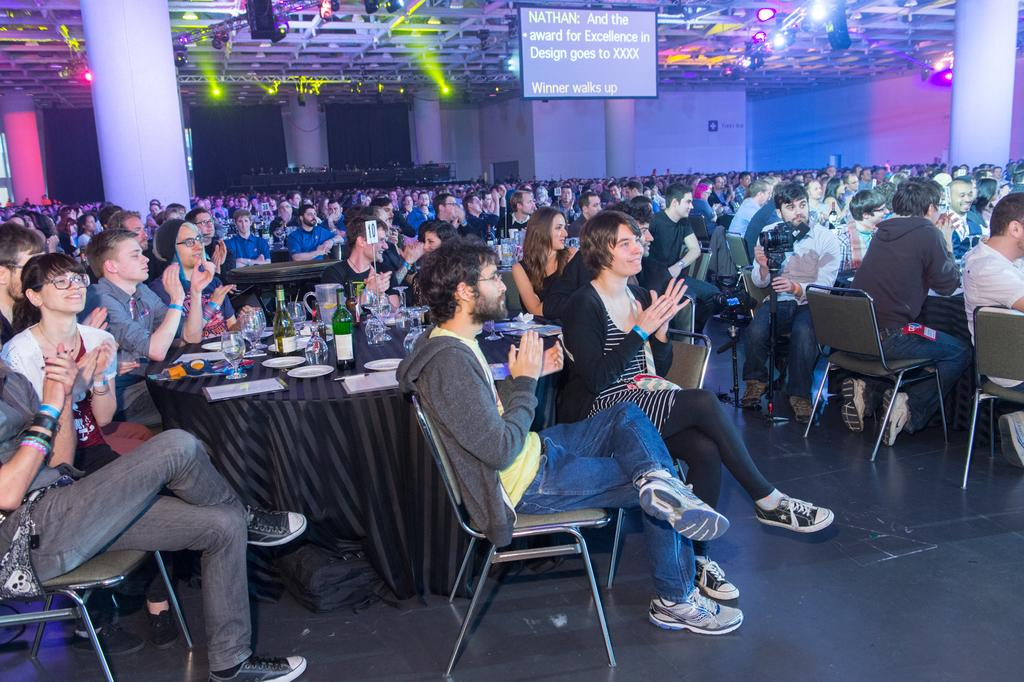What are the people in the image doing? There is a group of people sitting on chairs in the image. What can be seen on the table in the image? There is a glass, a bottle, a plate, and a pen on the table in the image. Are there any other objects on the table? Yes, there are other objects on the table in the image. What is located above the people in the image? There are lights on the top in the image. What is the purpose of the screen in the image? The purpose of the screen in the image is not specified, but it is present. Can you tell me how many kettles are on the table in the image? There is no kettle present on the table in the image. What type of club is being used by the people in the image? There is no club visible in the image; the people are sitting on chairs. 